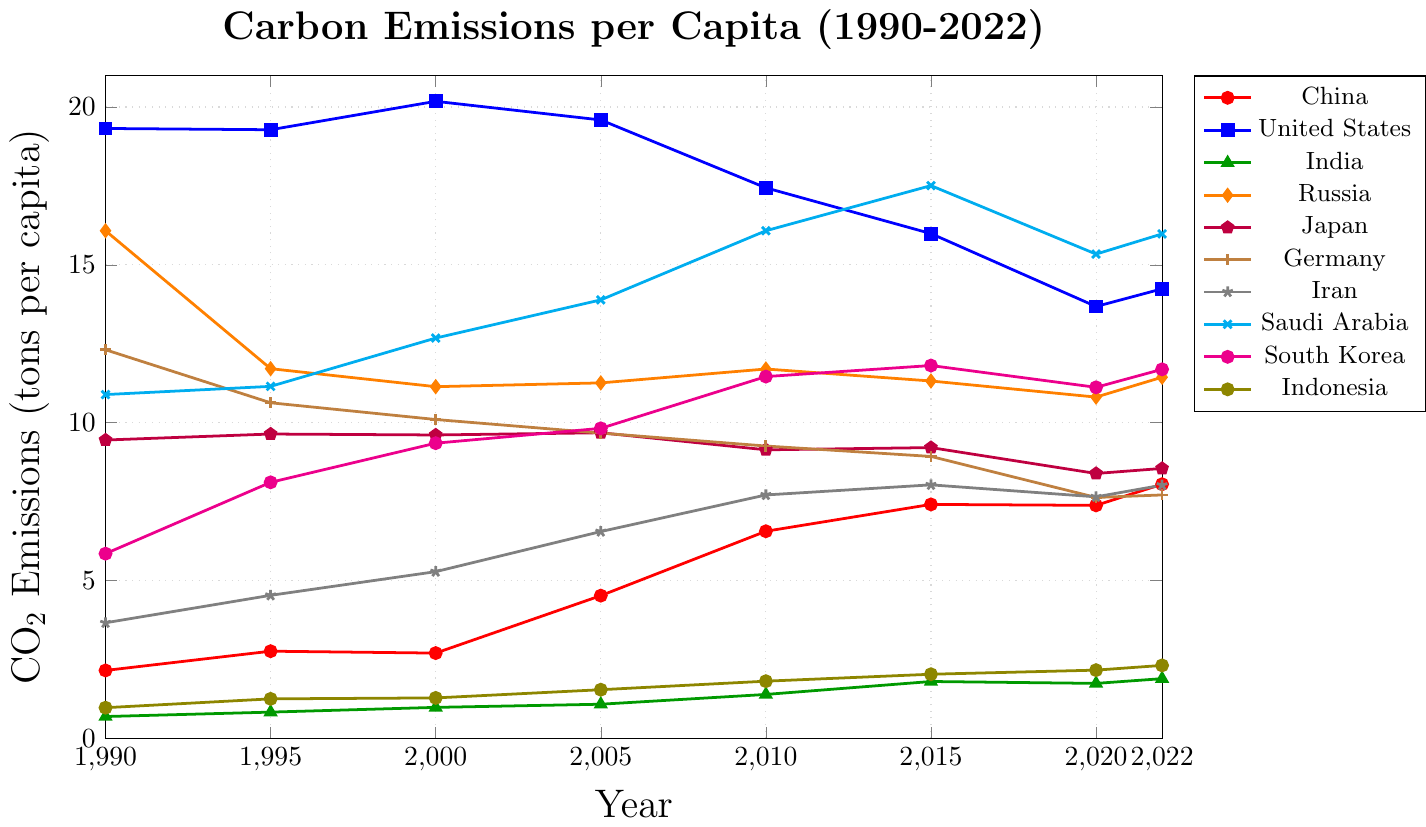What was the carbon emission per capita for China in 2005? In the chart, find the data point for China in the year 2005. The emission per capita for that year is represented by the y-coordinate of that point.
Answer: 4.52 Which country had the highest carbon emissions per capita in 1990? Look at the starting points of the lines representing each country in 1990 and identify the country with the highest y-coordinate.
Answer: United States How did the carbon emissions per capita for India change from 2000 to 2022? Find the data points for India in the years 2000 and 2022. Subtract the 2000 value from the 2022 value to find the change.
Answer: Increased by 0.91 Compare the carbon emissions per capita in 2022 between Germany and South Korea. Which country emitted more? Locate the data points for Germany and South Korea in 2022 and compare the y-coordinates.
Answer: South Korea For which country did the carbon emissions per capita decrease the most from 1990 to 2022? Calculate the change in emissions for each country between 1990 and 2022 by subtracting the 2022 value from the 1990 value. Identify the country with the largest decrease.
Answer: United States What is the average carbon emissions per capita for Saudi Arabia from 1990 to 2022? Add the emissions per capita values for Saudi Arabia from 1990, 1995, 2000, 2005, 2010, 2015, 2020, and 2022, then divide by the number of years (8).
Answer: 13.88 Identify the years in which Japan's carbon emissions per capita exceeded 9 tons. Look at the data points for Japan and find the years where the emissions per capita value is greater than 9.
Answer: 1990, 1995, 2000, 2005, 2010, 2015 Which two countries had the closest carbon emissions per capita in 2022? Compare the emission values for all countries in 2022 and find the two with the smallest difference.
Answer: Iran and Indonesia How did the trend of carbon emissions per capita for Russia change from 1990 to 2022? Identify the general direction of the Russian emissions over the years by observing the slope of the line. Note any periods of significant increase or decrease.
Answer: Decreased initially, then stable with slight fluctuations What's the difference in carbon emissions per capita between Saudi Arabia and Germany in 2015? Subtract the emission value for Germany in 2015 from the corresponding value for Saudi Arabia.
Answer: 8.58 